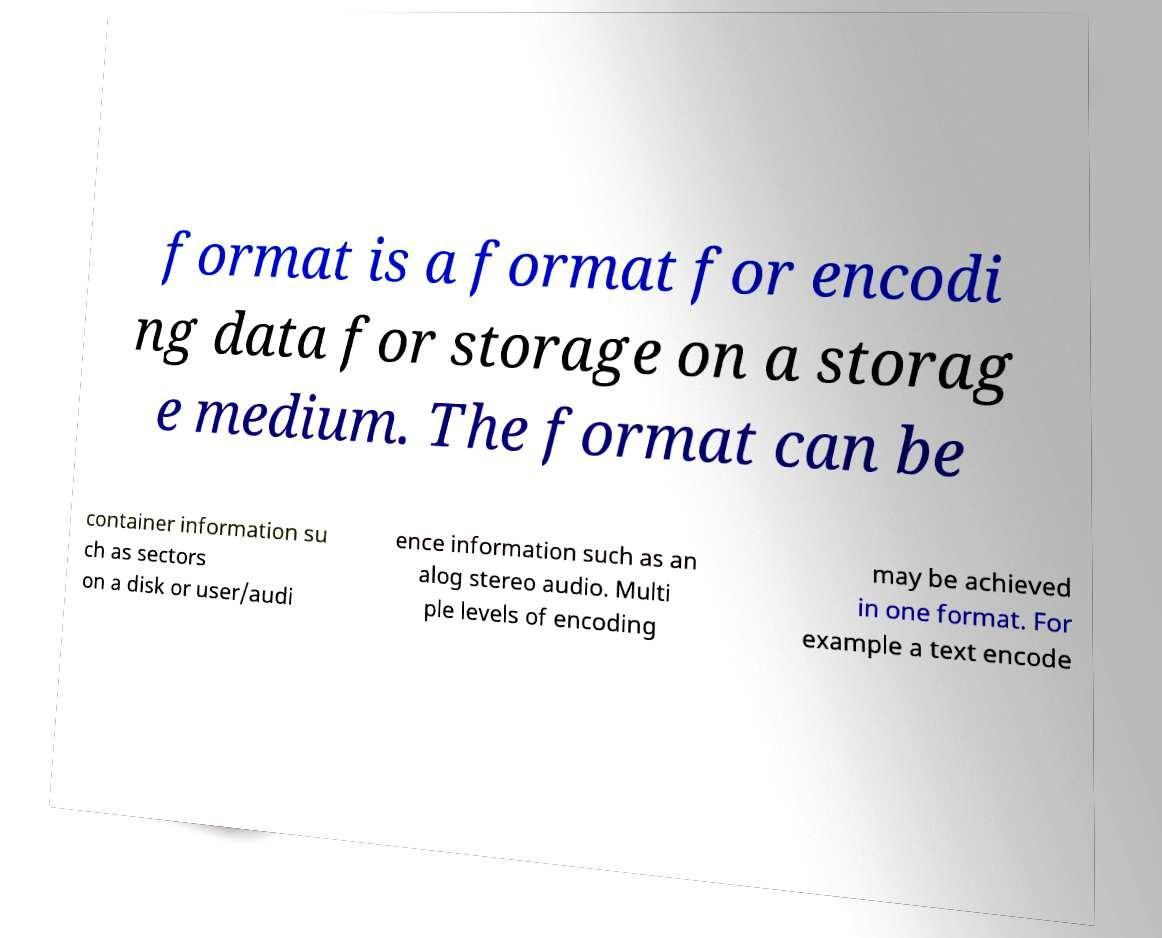I need the written content from this picture converted into text. Can you do that? format is a format for encodi ng data for storage on a storag e medium. The format can be container information su ch as sectors on a disk or user/audi ence information such as an alog stereo audio. Multi ple levels of encoding may be achieved in one format. For example a text encode 